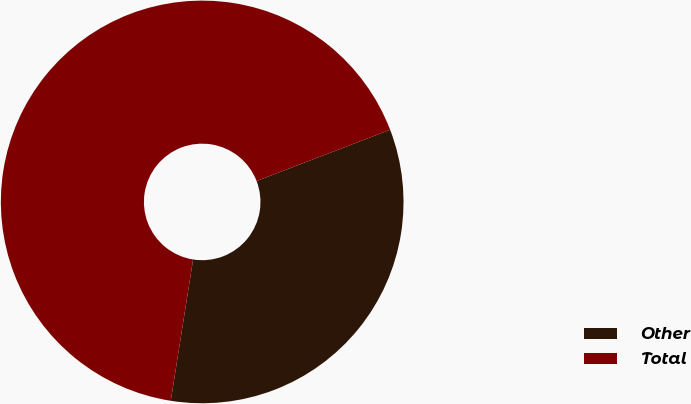<chart> <loc_0><loc_0><loc_500><loc_500><pie_chart><fcel>Other<fcel>Total<nl><fcel>33.33%<fcel>66.67%<nl></chart> 